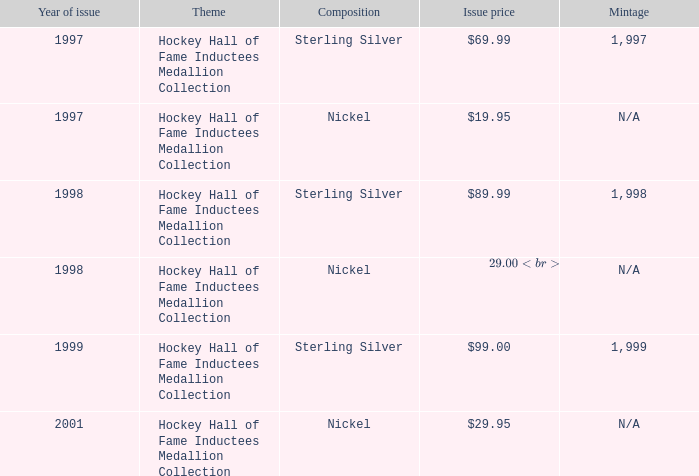95? 1.0. 